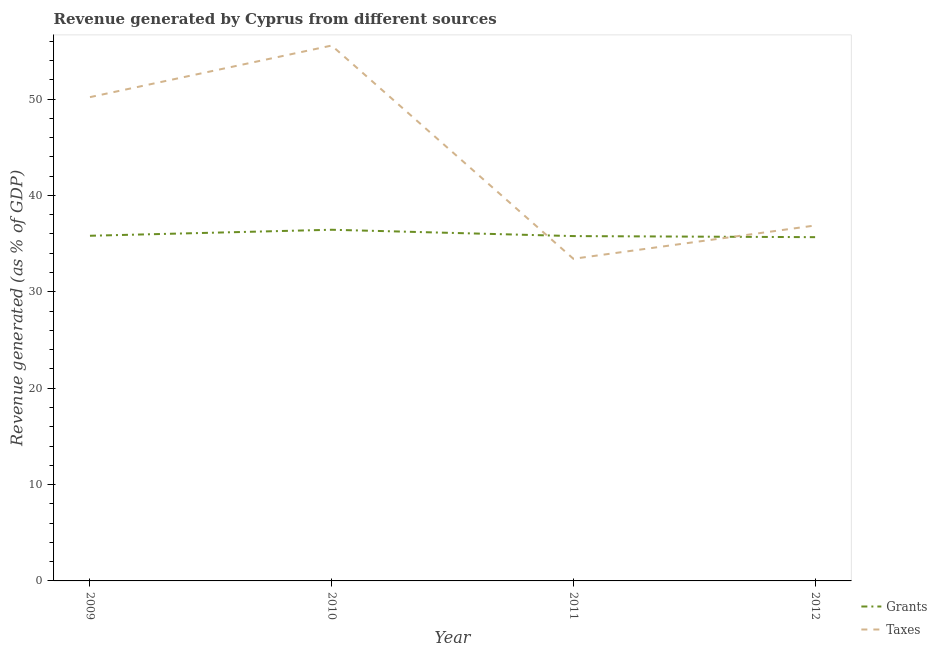Does the line corresponding to revenue generated by taxes intersect with the line corresponding to revenue generated by grants?
Offer a very short reply. Yes. What is the revenue generated by grants in 2012?
Your response must be concise. 35.67. Across all years, what is the maximum revenue generated by grants?
Your answer should be compact. 36.44. Across all years, what is the minimum revenue generated by taxes?
Make the answer very short. 33.43. In which year was the revenue generated by grants minimum?
Your response must be concise. 2012. What is the total revenue generated by grants in the graph?
Your answer should be compact. 143.71. What is the difference between the revenue generated by taxes in 2010 and that in 2012?
Offer a terse response. 18.67. What is the difference between the revenue generated by grants in 2012 and the revenue generated by taxes in 2009?
Offer a terse response. -14.53. What is the average revenue generated by taxes per year?
Your response must be concise. 44.02. In the year 2011, what is the difference between the revenue generated by grants and revenue generated by taxes?
Offer a very short reply. 2.36. In how many years, is the revenue generated by grants greater than 30 %?
Your response must be concise. 4. What is the ratio of the revenue generated by taxes in 2009 to that in 2010?
Keep it short and to the point. 0.9. Is the revenue generated by taxes in 2010 less than that in 2011?
Give a very brief answer. No. What is the difference between the highest and the second highest revenue generated by grants?
Ensure brevity in your answer.  0.62. What is the difference between the highest and the lowest revenue generated by grants?
Your response must be concise. 0.77. Is the revenue generated by taxes strictly less than the revenue generated by grants over the years?
Offer a terse response. No. How many years are there in the graph?
Make the answer very short. 4. What is the difference between two consecutive major ticks on the Y-axis?
Your answer should be very brief. 10. Are the values on the major ticks of Y-axis written in scientific E-notation?
Provide a succinct answer. No. Does the graph contain grids?
Your answer should be very brief. No. Where does the legend appear in the graph?
Provide a short and direct response. Bottom right. What is the title of the graph?
Make the answer very short. Revenue generated by Cyprus from different sources. Does "Birth rate" appear as one of the legend labels in the graph?
Offer a terse response. No. What is the label or title of the Y-axis?
Offer a very short reply. Revenue generated (as % of GDP). What is the Revenue generated (as % of GDP) of Grants in 2009?
Offer a very short reply. 35.82. What is the Revenue generated (as % of GDP) in Taxes in 2009?
Make the answer very short. 50.2. What is the Revenue generated (as % of GDP) of Grants in 2010?
Provide a short and direct response. 36.44. What is the Revenue generated (as % of GDP) of Taxes in 2010?
Provide a succinct answer. 55.56. What is the Revenue generated (as % of GDP) in Grants in 2011?
Provide a succinct answer. 35.78. What is the Revenue generated (as % of GDP) of Taxes in 2011?
Your answer should be very brief. 33.43. What is the Revenue generated (as % of GDP) of Grants in 2012?
Provide a succinct answer. 35.67. What is the Revenue generated (as % of GDP) in Taxes in 2012?
Provide a succinct answer. 36.88. Across all years, what is the maximum Revenue generated (as % of GDP) in Grants?
Provide a succinct answer. 36.44. Across all years, what is the maximum Revenue generated (as % of GDP) of Taxes?
Ensure brevity in your answer.  55.56. Across all years, what is the minimum Revenue generated (as % of GDP) of Grants?
Your response must be concise. 35.67. Across all years, what is the minimum Revenue generated (as % of GDP) in Taxes?
Provide a succinct answer. 33.43. What is the total Revenue generated (as % of GDP) in Grants in the graph?
Your answer should be very brief. 143.71. What is the total Revenue generated (as % of GDP) of Taxes in the graph?
Keep it short and to the point. 176.07. What is the difference between the Revenue generated (as % of GDP) in Grants in 2009 and that in 2010?
Make the answer very short. -0.62. What is the difference between the Revenue generated (as % of GDP) of Taxes in 2009 and that in 2010?
Ensure brevity in your answer.  -5.35. What is the difference between the Revenue generated (as % of GDP) in Grants in 2009 and that in 2011?
Your answer should be very brief. 0.03. What is the difference between the Revenue generated (as % of GDP) of Taxes in 2009 and that in 2011?
Provide a short and direct response. 16.78. What is the difference between the Revenue generated (as % of GDP) in Grants in 2009 and that in 2012?
Offer a very short reply. 0.14. What is the difference between the Revenue generated (as % of GDP) in Taxes in 2009 and that in 2012?
Your answer should be very brief. 13.32. What is the difference between the Revenue generated (as % of GDP) in Grants in 2010 and that in 2011?
Provide a succinct answer. 0.66. What is the difference between the Revenue generated (as % of GDP) in Taxes in 2010 and that in 2011?
Offer a terse response. 22.13. What is the difference between the Revenue generated (as % of GDP) in Grants in 2010 and that in 2012?
Offer a very short reply. 0.77. What is the difference between the Revenue generated (as % of GDP) of Taxes in 2010 and that in 2012?
Keep it short and to the point. 18.67. What is the difference between the Revenue generated (as % of GDP) of Grants in 2011 and that in 2012?
Ensure brevity in your answer.  0.11. What is the difference between the Revenue generated (as % of GDP) of Taxes in 2011 and that in 2012?
Ensure brevity in your answer.  -3.46. What is the difference between the Revenue generated (as % of GDP) in Grants in 2009 and the Revenue generated (as % of GDP) in Taxes in 2010?
Your answer should be compact. -19.74. What is the difference between the Revenue generated (as % of GDP) of Grants in 2009 and the Revenue generated (as % of GDP) of Taxes in 2011?
Ensure brevity in your answer.  2.39. What is the difference between the Revenue generated (as % of GDP) of Grants in 2009 and the Revenue generated (as % of GDP) of Taxes in 2012?
Your answer should be very brief. -1.07. What is the difference between the Revenue generated (as % of GDP) in Grants in 2010 and the Revenue generated (as % of GDP) in Taxes in 2011?
Offer a very short reply. 3.01. What is the difference between the Revenue generated (as % of GDP) of Grants in 2010 and the Revenue generated (as % of GDP) of Taxes in 2012?
Give a very brief answer. -0.44. What is the difference between the Revenue generated (as % of GDP) in Grants in 2011 and the Revenue generated (as % of GDP) in Taxes in 2012?
Your answer should be very brief. -1.1. What is the average Revenue generated (as % of GDP) in Grants per year?
Your response must be concise. 35.93. What is the average Revenue generated (as % of GDP) of Taxes per year?
Keep it short and to the point. 44.02. In the year 2009, what is the difference between the Revenue generated (as % of GDP) of Grants and Revenue generated (as % of GDP) of Taxes?
Your response must be concise. -14.39. In the year 2010, what is the difference between the Revenue generated (as % of GDP) in Grants and Revenue generated (as % of GDP) in Taxes?
Offer a terse response. -19.12. In the year 2011, what is the difference between the Revenue generated (as % of GDP) in Grants and Revenue generated (as % of GDP) in Taxes?
Make the answer very short. 2.36. In the year 2012, what is the difference between the Revenue generated (as % of GDP) of Grants and Revenue generated (as % of GDP) of Taxes?
Your answer should be very brief. -1.21. What is the ratio of the Revenue generated (as % of GDP) of Grants in 2009 to that in 2010?
Ensure brevity in your answer.  0.98. What is the ratio of the Revenue generated (as % of GDP) in Taxes in 2009 to that in 2010?
Give a very brief answer. 0.9. What is the ratio of the Revenue generated (as % of GDP) in Grants in 2009 to that in 2011?
Offer a terse response. 1. What is the ratio of the Revenue generated (as % of GDP) of Taxes in 2009 to that in 2011?
Give a very brief answer. 1.5. What is the ratio of the Revenue generated (as % of GDP) in Grants in 2009 to that in 2012?
Keep it short and to the point. 1. What is the ratio of the Revenue generated (as % of GDP) of Taxes in 2009 to that in 2012?
Ensure brevity in your answer.  1.36. What is the ratio of the Revenue generated (as % of GDP) of Grants in 2010 to that in 2011?
Give a very brief answer. 1.02. What is the ratio of the Revenue generated (as % of GDP) of Taxes in 2010 to that in 2011?
Your answer should be compact. 1.66. What is the ratio of the Revenue generated (as % of GDP) in Grants in 2010 to that in 2012?
Keep it short and to the point. 1.02. What is the ratio of the Revenue generated (as % of GDP) of Taxes in 2010 to that in 2012?
Your answer should be compact. 1.51. What is the ratio of the Revenue generated (as % of GDP) in Grants in 2011 to that in 2012?
Your answer should be very brief. 1. What is the ratio of the Revenue generated (as % of GDP) in Taxes in 2011 to that in 2012?
Provide a short and direct response. 0.91. What is the difference between the highest and the second highest Revenue generated (as % of GDP) in Grants?
Make the answer very short. 0.62. What is the difference between the highest and the second highest Revenue generated (as % of GDP) in Taxes?
Provide a short and direct response. 5.35. What is the difference between the highest and the lowest Revenue generated (as % of GDP) in Grants?
Provide a short and direct response. 0.77. What is the difference between the highest and the lowest Revenue generated (as % of GDP) of Taxes?
Provide a short and direct response. 22.13. 